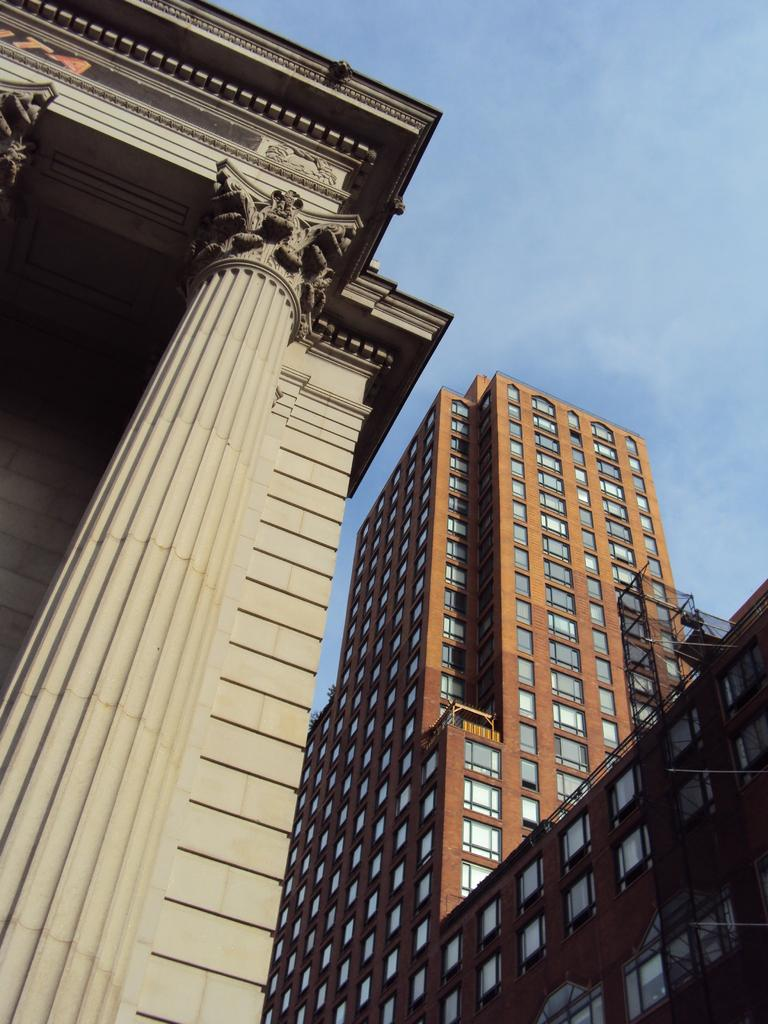What is the main structure in the image? There is a tall tower in the image. What feature of the tower is mentioned in the facts? The tower has plenty of windows. What other large structure is present in the image? There is a huge building beside the tower. What type of decorations can be seen on the building? The building has carvings on its pillars and carvings on its wall. Can you tell me how many sisters are visible in the image? There is no mention of a sister or any people in the image; it primarily features the tall tower and the huge building. 